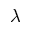<formula> <loc_0><loc_0><loc_500><loc_500>\lambda</formula> 